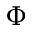Convert formula to latex. <formula><loc_0><loc_0><loc_500><loc_500>\Phi</formula> 